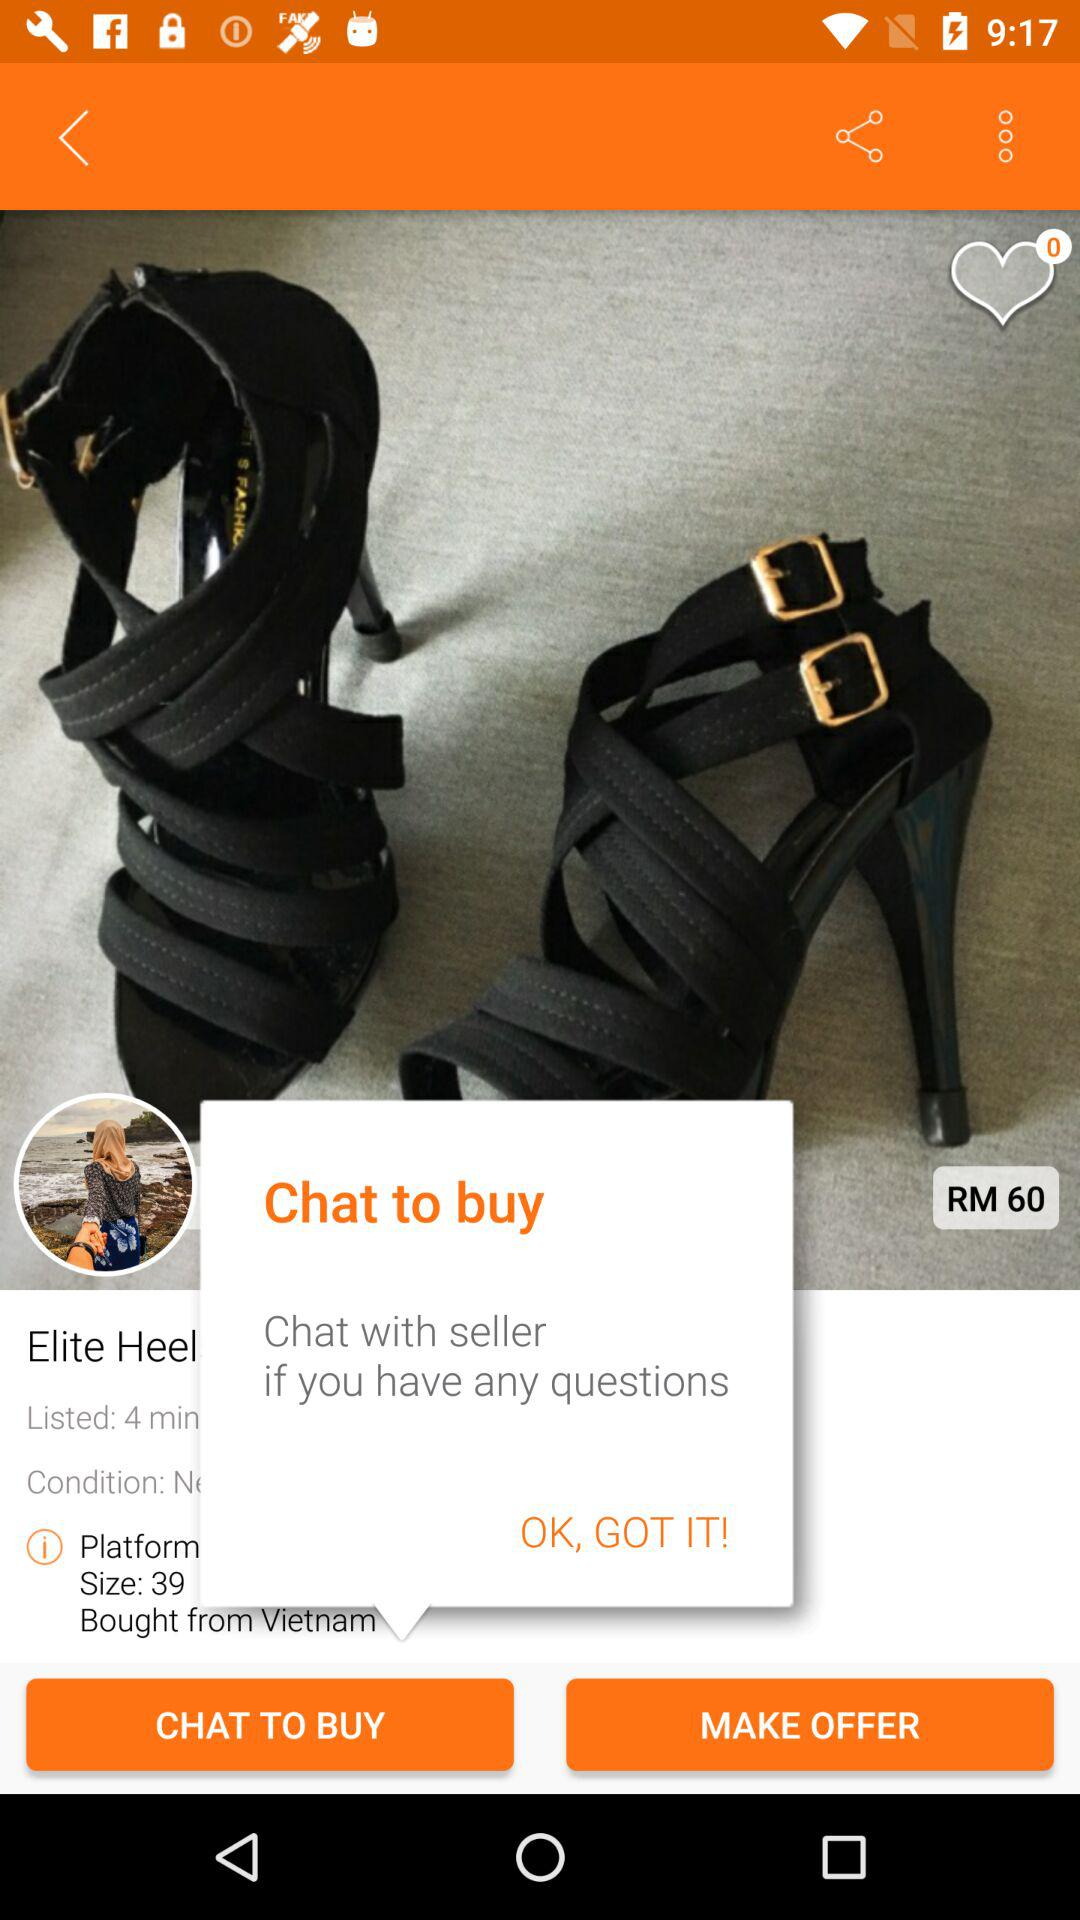What is the seller's location?
Answer the question using a single word or phrase. Vietnam 